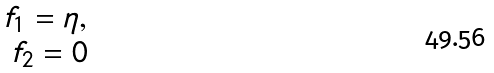Convert formula to latex. <formula><loc_0><loc_0><loc_500><loc_500>\begin{array} { r } f _ { 1 } = \eta , \\ f _ { 2 } = 0 \\ \end{array}</formula> 